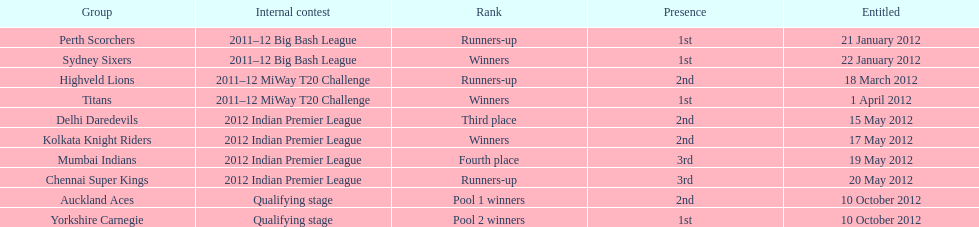Which game came in first in the 2012 indian premier league? Kolkata Knight Riders. 